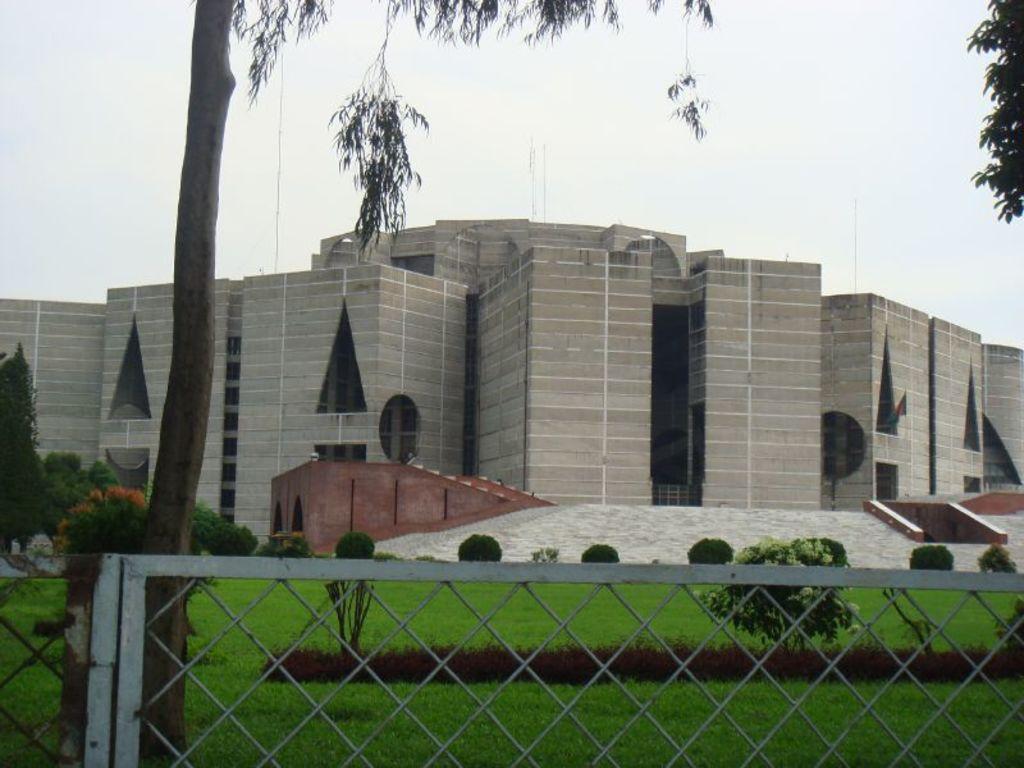Please provide a concise description of this image. We can see fence, plants, grass and trees. In the background we can see building and sky. 